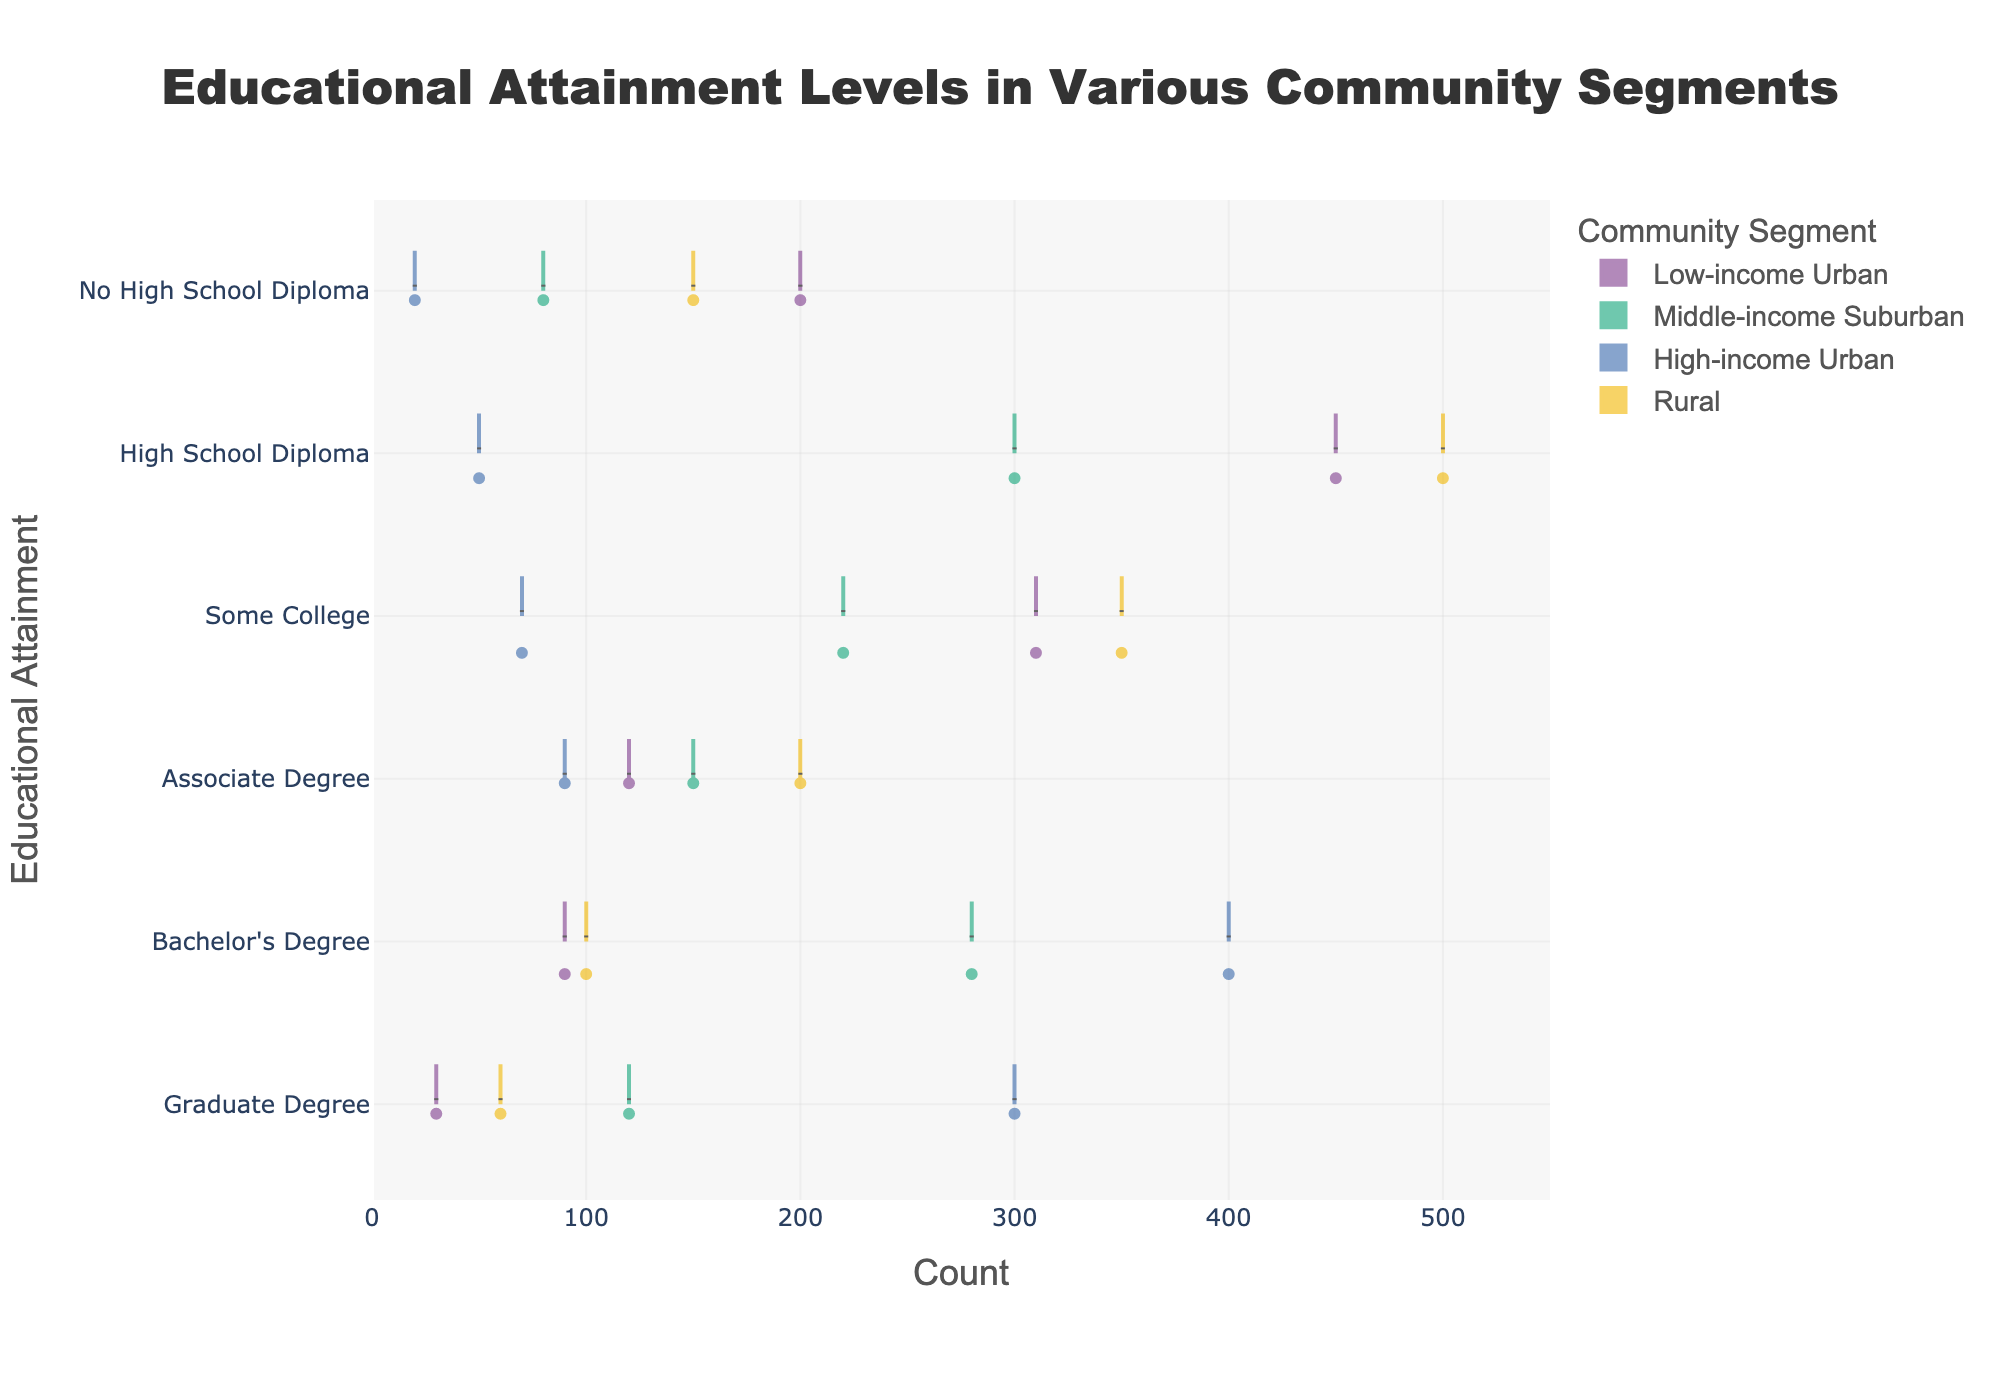what is the title of the figure? The title of the figure is usually prominently displayed at the top. It provides an overview of what the figure represents.
Answer: Educational Attainment Levels in Various Community Segments What are the educational attainment levels presented in the chart? The educational attainment levels are listed on the y-axis.
Answer: No High School Diploma, High School Diploma, Some College, Associate Degree, Bachelor's Degree, Graduate Degree Which community segment has the highest count of individuals with a High School Diploma? By observing the x-axis for the educational attainment "High School Diploma" and comparing the lengths of the violins, the "Rural" segment extends the farthest to the right, indicating the highest count.
Answer: Rural How many educational attainment categories are there? Count the distinct educational attainment levels listed on the y-axis.
Answer: 6 What is the average count of individuals with a Bachelor's Degree in all segments? Sum the counts of individuals with a Bachelor's Degree (90 + 280 + 400 + 100 = 870) and then divide by the number of segments (4).
Answer: 217.5 Which community segment has the least variation in the distribution of counts for educational attainment? The High-income Urban segment's violins appear narrower across most educational attainment levels, indicating less variation compared to others.
Answer: High-income Urban Compare the counts of individuals with no high school diploma between Low-income Urban and Rural segments. Which is higher? By comparing the lengths of the violins for "No High School Diploma" in the "Low-income Urban" and "Rural" segments, it's evident that the "Low-income Urban" segment has a longer violin.
Answer: Low-income Urban In which community segment is the median count for "Graduate Degree" higher: Middle-income Suburban or High-income Urban? The median is represented by the white line within the box plot inside each violin. The white line appears higher for the "High-income Urban" segment compared to the "Middle-income Suburban" segment for "Graduate Degree".
Answer: High-income Urban What is the count difference between individuals holding an Associate Degree in Low-income Urban and Rural segments? Subtract the count of individuals with an Associate Degree in Low-income Urban (120) from Rural (200).
Answer: 80 For which community segment is the mean line for the "Some College" attainment level the lowest? The mean is indicated by the black line. For the "Some College" attainment level, the mean line is lowest in the "High-income Urban" segment.
Answer: High-income Urban 